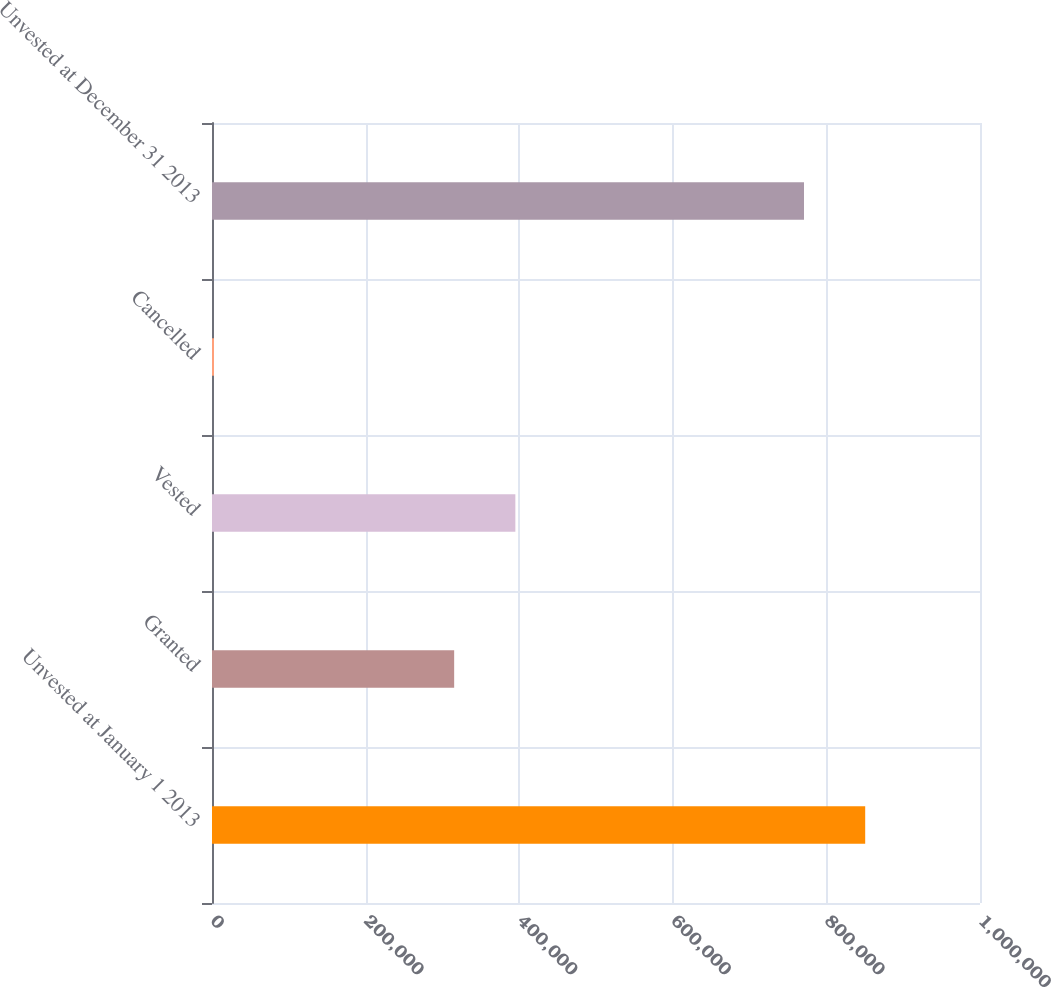Convert chart to OTSL. <chart><loc_0><loc_0><loc_500><loc_500><bar_chart><fcel>Unvested at January 1 2013<fcel>Granted<fcel>Vested<fcel>Cancelled<fcel>Unvested at December 31 2013<nl><fcel>850516<fcel>315316<fcel>395002<fcel>2633<fcel>770830<nl></chart> 